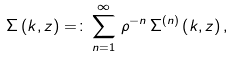Convert formula to latex. <formula><loc_0><loc_0><loc_500><loc_500>\Sigma \left ( k , z \right ) = \colon \sum _ { n = 1 } ^ { \infty } \, \rho ^ { - n } \, \Sigma ^ { ( n ) } \left ( k , z \right ) ,</formula> 